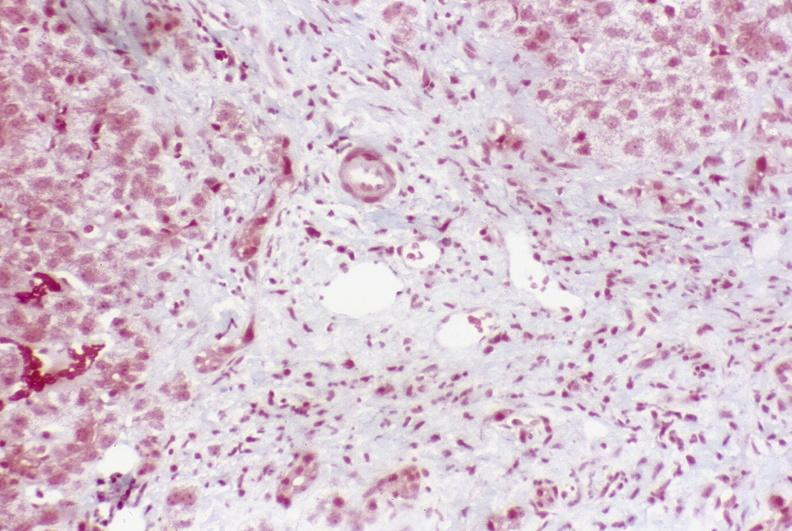s left ventricle hypertrophy present?
Answer the question using a single word or phrase. No 